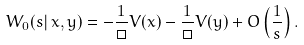<formula> <loc_0><loc_0><loc_500><loc_500>W _ { 0 } ( s | \, x , y ) = - \frac { 1 } { \Box } V ( x ) - \frac { 1 } { \Box } V ( y ) + O \left ( \frac { 1 } { s } \right ) .</formula> 